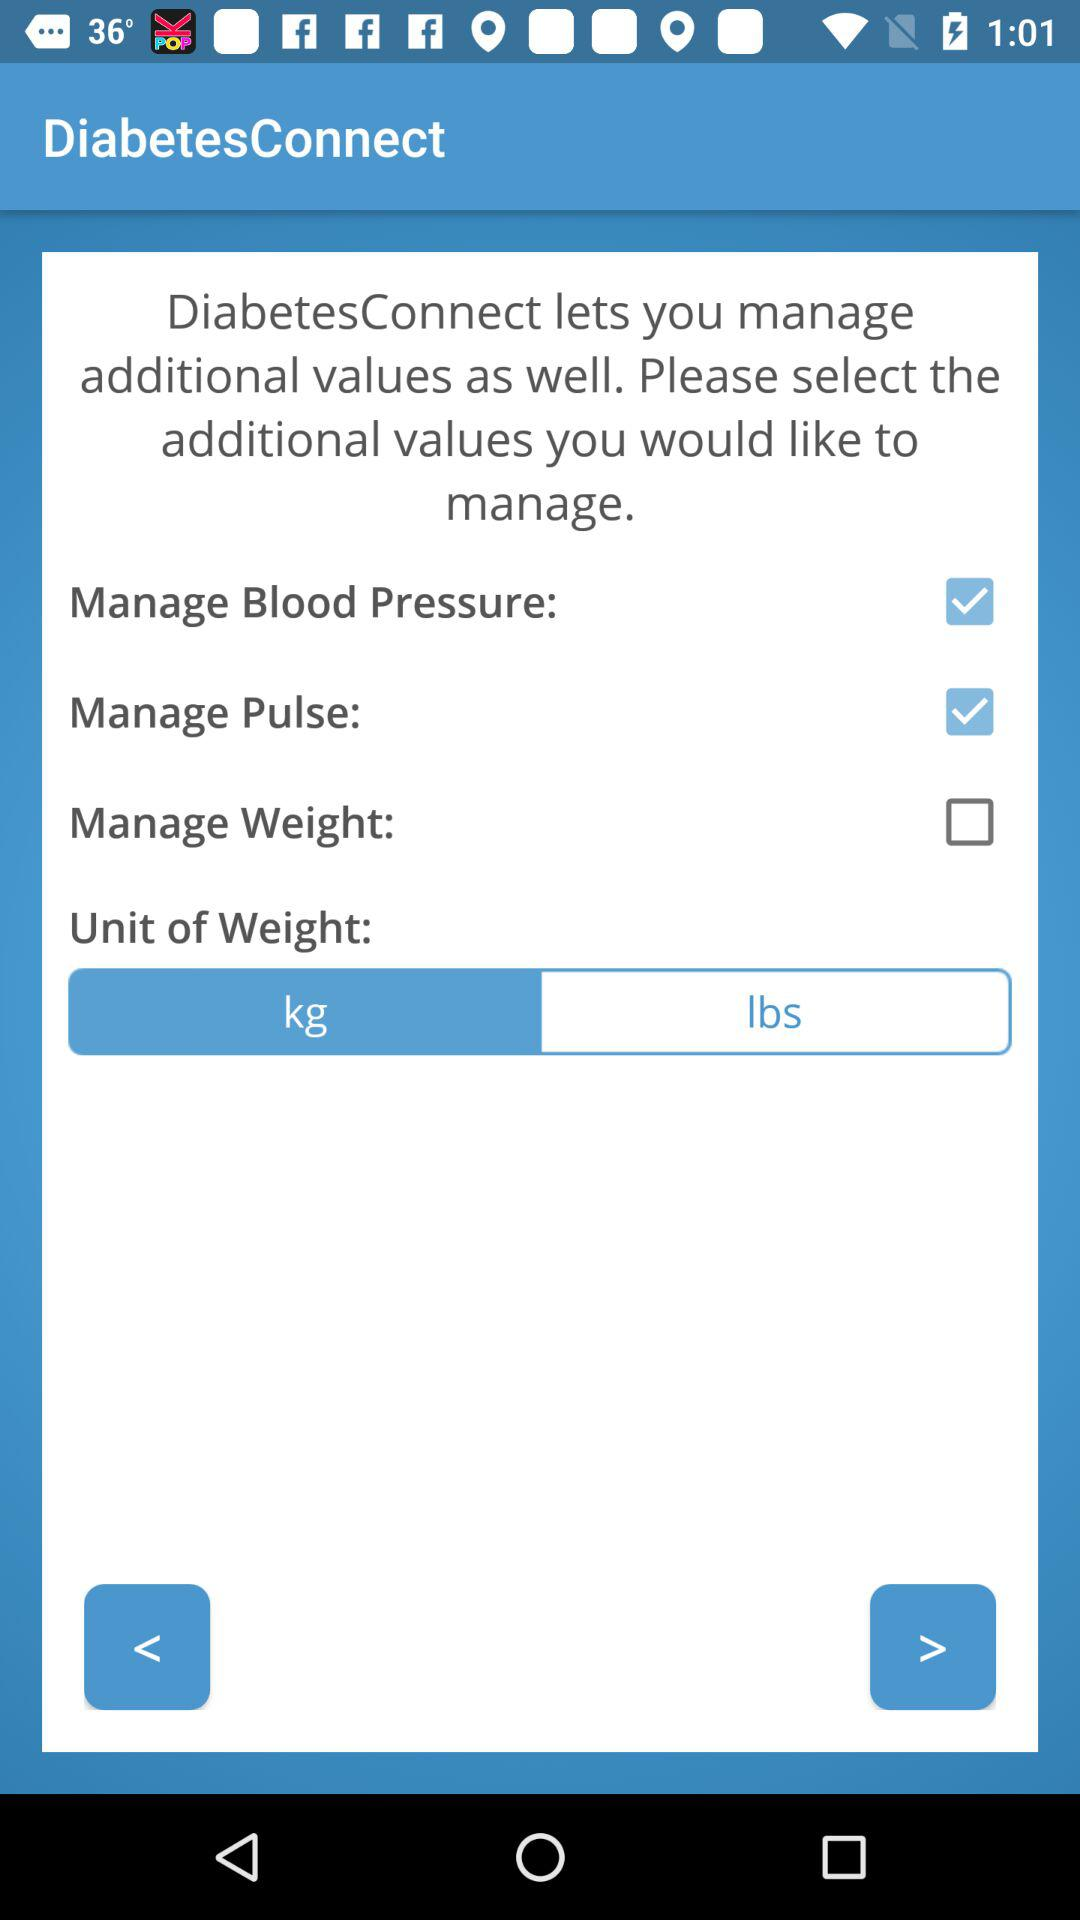What are the units of weight? The units are kilograms and pounds. 